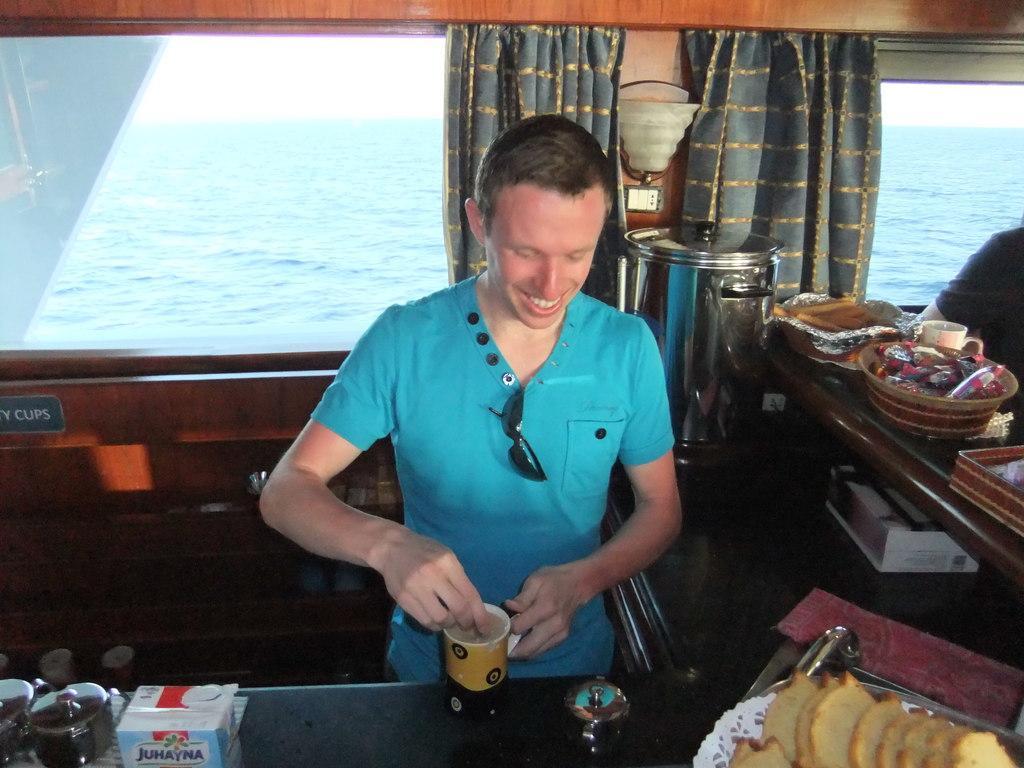Could you give a brief overview of what you see in this image? In this picture we can see a person holding a cup, here we can see a kitchen platform, bowls, food items, boxes, another person hand, wall, name board, windows, curtains and some objects and from windows we can see water. 